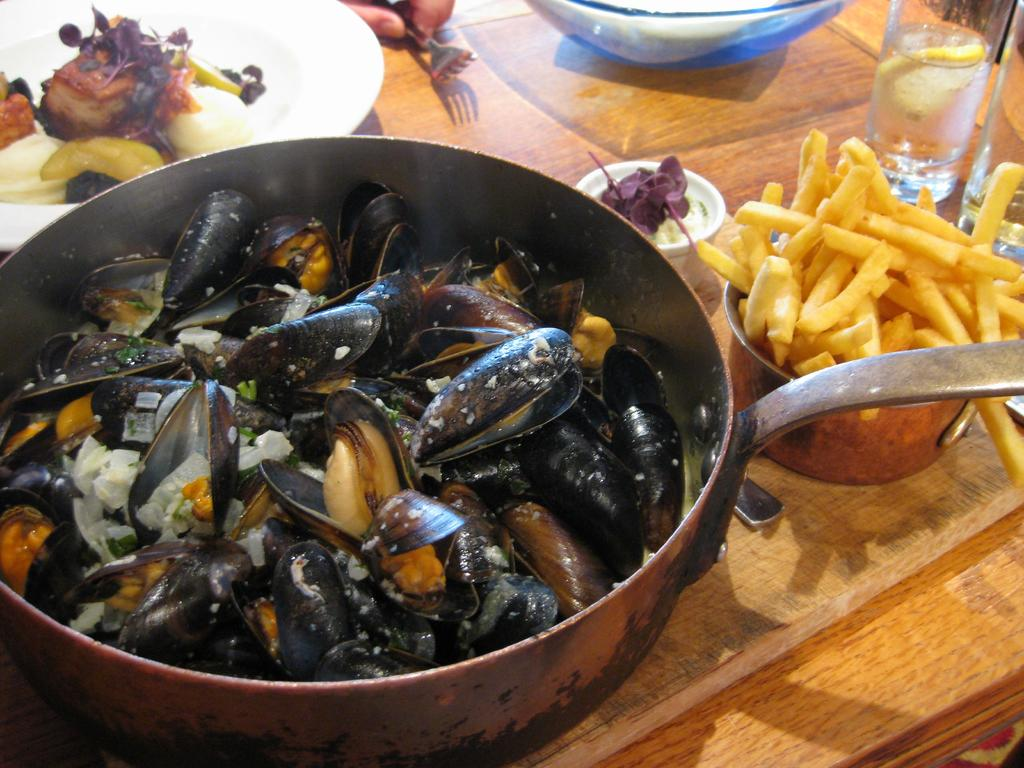What type of food is being cooked in the pan in the image? There are mussels in a pan in the image. What other type of food is visible in the image? There are french fries in the image. What is the drink that can be seen in the image? There is a water glass in the image. On what surface are the objects placed in the image? The objects are placed on a wooden table top. Are there any dinosaurs visible in the image? No, there are no dinosaurs present in the image. Can you see a fly on the french fries in the image? There is no mention of a fly in the image, so we cannot determine if one is present or not. 